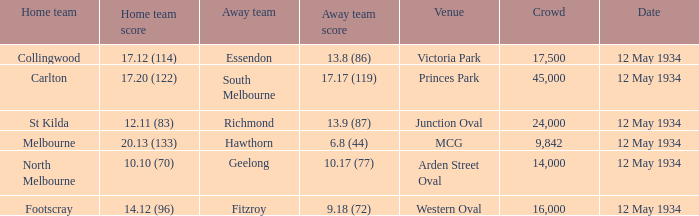What was the score of the away team while playing at the arden street oval? 10.17 (77). 